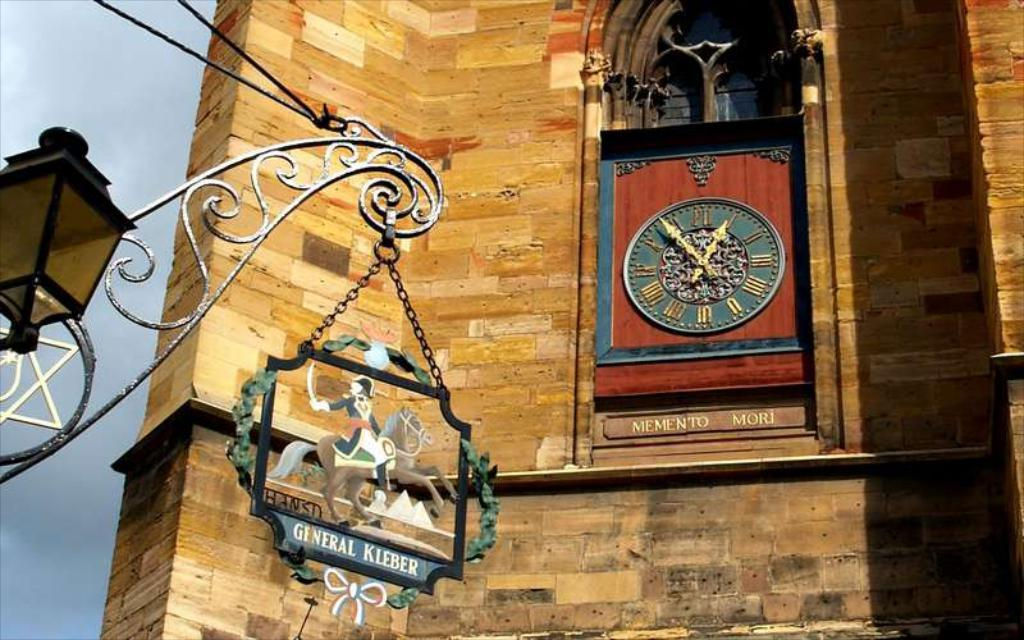<image>
Write a terse but informative summary of the picture. A sign featuring a person on a horse says General Kleber. 